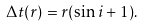<formula> <loc_0><loc_0><loc_500><loc_500>\Delta t ( r ) = r ( \sin i + 1 ) .</formula> 